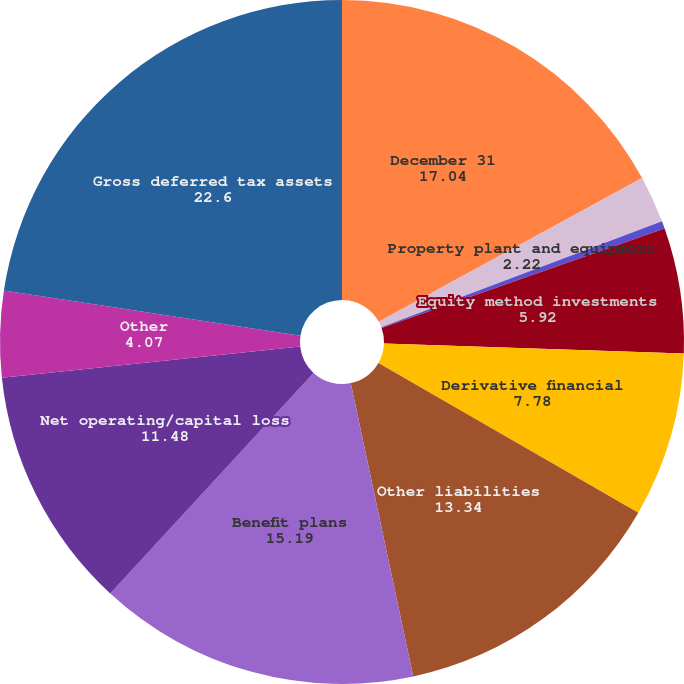Convert chart. <chart><loc_0><loc_0><loc_500><loc_500><pie_chart><fcel>December 31<fcel>Property plant and equipment<fcel>Trademarks and other<fcel>Equity method investments<fcel>Derivative financial<fcel>Other liabilities<fcel>Benefit plans<fcel>Net operating/capital loss<fcel>Other<fcel>Gross deferred tax assets<nl><fcel>17.04%<fcel>2.22%<fcel>0.36%<fcel>5.92%<fcel>7.78%<fcel>13.34%<fcel>15.19%<fcel>11.48%<fcel>4.07%<fcel>22.6%<nl></chart> 